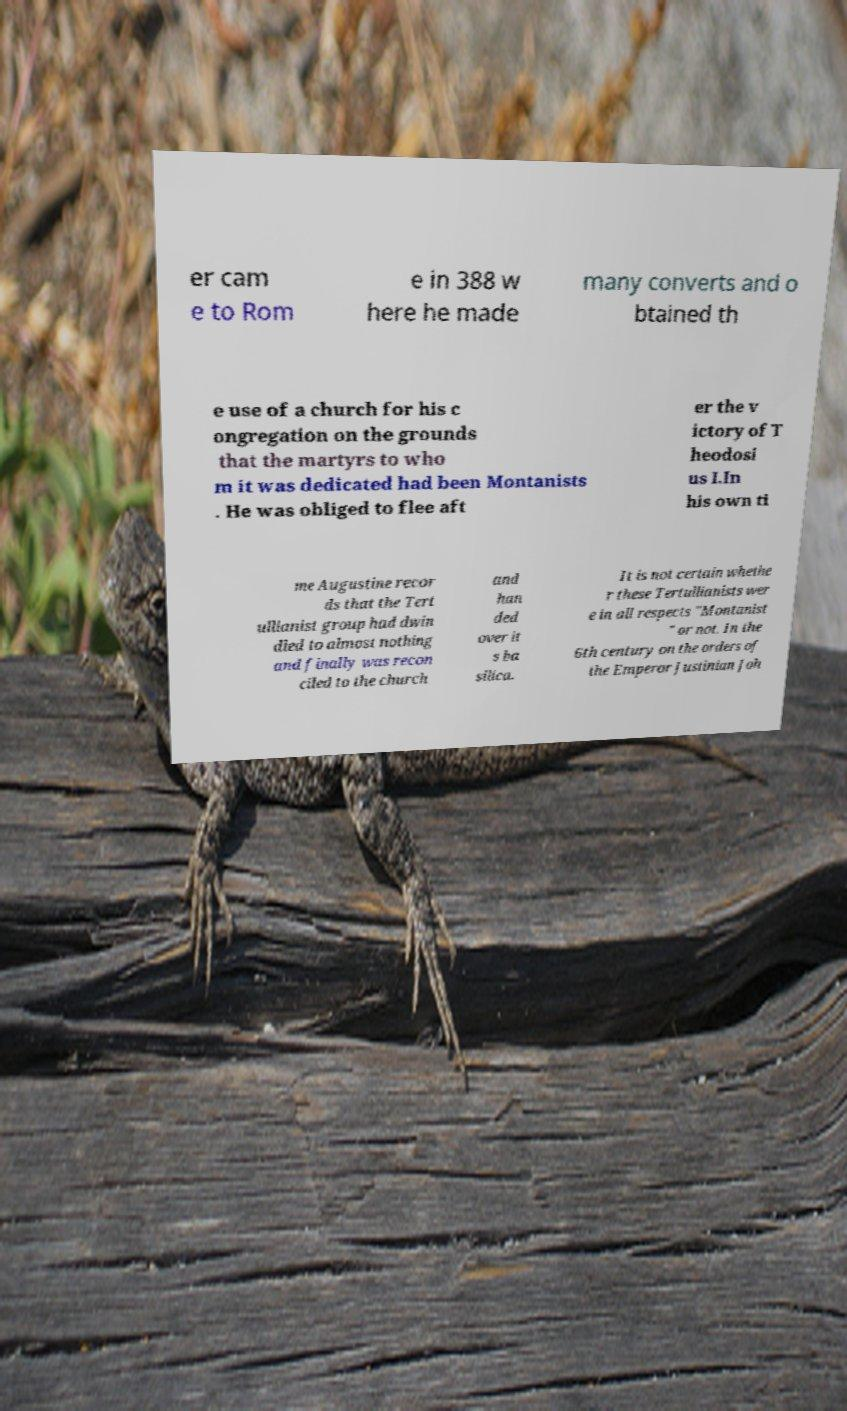Can you read and provide the text displayed in the image?This photo seems to have some interesting text. Can you extract and type it out for me? er cam e to Rom e in 388 w here he made many converts and o btained th e use of a church for his c ongregation on the grounds that the martyrs to who m it was dedicated had been Montanists . He was obliged to flee aft er the v ictory of T heodosi us I.In his own ti me Augustine recor ds that the Tert ullianist group had dwin dled to almost nothing and finally was recon ciled to the church and han ded over it s ba silica. It is not certain whethe r these Tertullianists wer e in all respects "Montanist " or not. In the 6th century on the orders of the Emperor Justinian Joh 